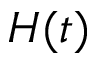<formula> <loc_0><loc_0><loc_500><loc_500>H ( t )</formula> 